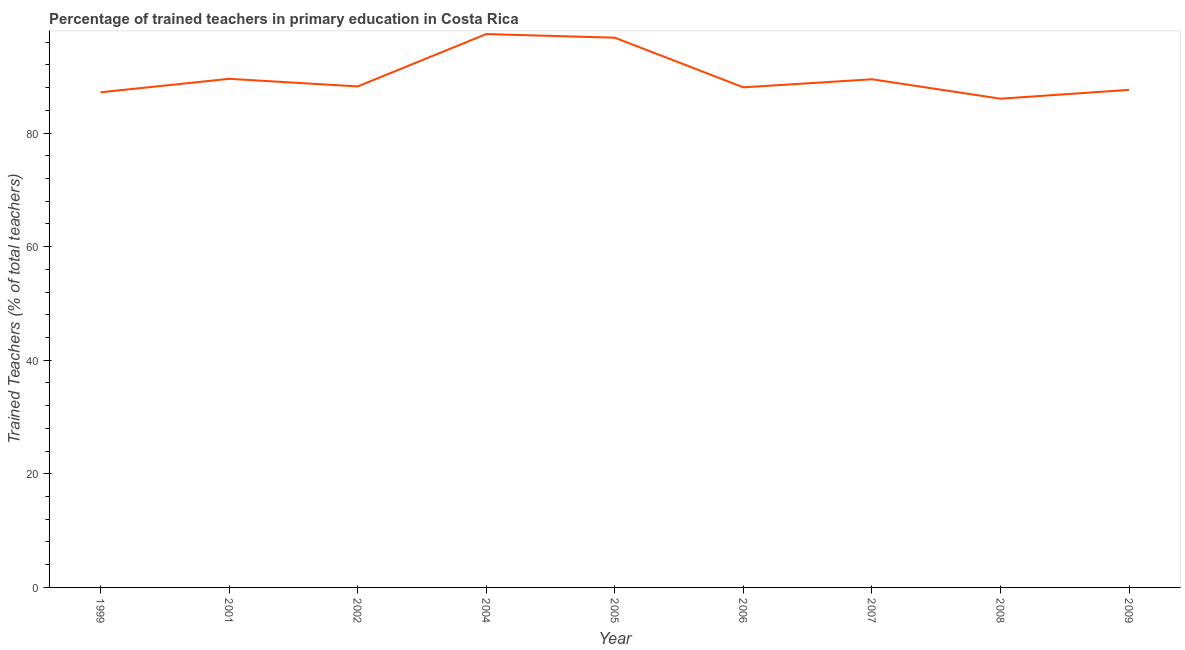What is the percentage of trained teachers in 2007?
Provide a succinct answer. 89.47. Across all years, what is the maximum percentage of trained teachers?
Your answer should be compact. 97.43. Across all years, what is the minimum percentage of trained teachers?
Keep it short and to the point. 86.05. In which year was the percentage of trained teachers maximum?
Your response must be concise. 2004. What is the sum of the percentage of trained teachers?
Your response must be concise. 810.29. What is the difference between the percentage of trained teachers in 2008 and 2009?
Your answer should be compact. -1.55. What is the average percentage of trained teachers per year?
Keep it short and to the point. 90.03. What is the median percentage of trained teachers?
Your answer should be very brief. 88.21. In how many years, is the percentage of trained teachers greater than 88 %?
Your response must be concise. 6. What is the ratio of the percentage of trained teachers in 1999 to that in 2006?
Your answer should be very brief. 0.99. Is the percentage of trained teachers in 2004 less than that in 2006?
Provide a succinct answer. No. Is the difference between the percentage of trained teachers in 2001 and 2006 greater than the difference between any two years?
Provide a succinct answer. No. What is the difference between the highest and the second highest percentage of trained teachers?
Give a very brief answer. 0.64. What is the difference between the highest and the lowest percentage of trained teachers?
Make the answer very short. 11.38. In how many years, is the percentage of trained teachers greater than the average percentage of trained teachers taken over all years?
Provide a succinct answer. 2. How many lines are there?
Give a very brief answer. 1. Does the graph contain grids?
Your answer should be compact. No. What is the title of the graph?
Your answer should be compact. Percentage of trained teachers in primary education in Costa Rica. What is the label or title of the Y-axis?
Provide a short and direct response. Trained Teachers (% of total teachers). What is the Trained Teachers (% of total teachers) of 1999?
Keep it short and to the point. 87.18. What is the Trained Teachers (% of total teachers) in 2001?
Your response must be concise. 89.54. What is the Trained Teachers (% of total teachers) in 2002?
Offer a terse response. 88.21. What is the Trained Teachers (% of total teachers) in 2004?
Make the answer very short. 97.43. What is the Trained Teachers (% of total teachers) in 2005?
Your response must be concise. 96.79. What is the Trained Teachers (% of total teachers) of 2006?
Offer a very short reply. 88.04. What is the Trained Teachers (% of total teachers) in 2007?
Make the answer very short. 89.47. What is the Trained Teachers (% of total teachers) in 2008?
Offer a terse response. 86.05. What is the Trained Teachers (% of total teachers) of 2009?
Provide a short and direct response. 87.6. What is the difference between the Trained Teachers (% of total teachers) in 1999 and 2001?
Offer a very short reply. -2.37. What is the difference between the Trained Teachers (% of total teachers) in 1999 and 2002?
Ensure brevity in your answer.  -1.03. What is the difference between the Trained Teachers (% of total teachers) in 1999 and 2004?
Offer a terse response. -10.25. What is the difference between the Trained Teachers (% of total teachers) in 1999 and 2005?
Your answer should be very brief. -9.61. What is the difference between the Trained Teachers (% of total teachers) in 1999 and 2006?
Your answer should be compact. -0.87. What is the difference between the Trained Teachers (% of total teachers) in 1999 and 2007?
Offer a terse response. -2.29. What is the difference between the Trained Teachers (% of total teachers) in 1999 and 2008?
Offer a very short reply. 1.13. What is the difference between the Trained Teachers (% of total teachers) in 1999 and 2009?
Your response must be concise. -0.42. What is the difference between the Trained Teachers (% of total teachers) in 2001 and 2002?
Your response must be concise. 1.34. What is the difference between the Trained Teachers (% of total teachers) in 2001 and 2004?
Offer a very short reply. -7.88. What is the difference between the Trained Teachers (% of total teachers) in 2001 and 2005?
Provide a succinct answer. -7.24. What is the difference between the Trained Teachers (% of total teachers) in 2001 and 2006?
Provide a succinct answer. 1.5. What is the difference between the Trained Teachers (% of total teachers) in 2001 and 2007?
Offer a very short reply. 0.08. What is the difference between the Trained Teachers (% of total teachers) in 2001 and 2008?
Make the answer very short. 3.5. What is the difference between the Trained Teachers (% of total teachers) in 2001 and 2009?
Your answer should be very brief. 1.94. What is the difference between the Trained Teachers (% of total teachers) in 2002 and 2004?
Offer a terse response. -9.22. What is the difference between the Trained Teachers (% of total teachers) in 2002 and 2005?
Keep it short and to the point. -8.58. What is the difference between the Trained Teachers (% of total teachers) in 2002 and 2006?
Provide a succinct answer. 0.16. What is the difference between the Trained Teachers (% of total teachers) in 2002 and 2007?
Offer a terse response. -1.26. What is the difference between the Trained Teachers (% of total teachers) in 2002 and 2008?
Provide a short and direct response. 2.16. What is the difference between the Trained Teachers (% of total teachers) in 2002 and 2009?
Your answer should be compact. 0.61. What is the difference between the Trained Teachers (% of total teachers) in 2004 and 2005?
Offer a terse response. 0.64. What is the difference between the Trained Teachers (% of total teachers) in 2004 and 2006?
Give a very brief answer. 9.38. What is the difference between the Trained Teachers (% of total teachers) in 2004 and 2007?
Make the answer very short. 7.96. What is the difference between the Trained Teachers (% of total teachers) in 2004 and 2008?
Give a very brief answer. 11.38. What is the difference between the Trained Teachers (% of total teachers) in 2004 and 2009?
Your answer should be very brief. 9.83. What is the difference between the Trained Teachers (% of total teachers) in 2005 and 2006?
Keep it short and to the point. 8.74. What is the difference between the Trained Teachers (% of total teachers) in 2005 and 2007?
Make the answer very short. 7.32. What is the difference between the Trained Teachers (% of total teachers) in 2005 and 2008?
Give a very brief answer. 10.74. What is the difference between the Trained Teachers (% of total teachers) in 2005 and 2009?
Provide a short and direct response. 9.19. What is the difference between the Trained Teachers (% of total teachers) in 2006 and 2007?
Keep it short and to the point. -1.42. What is the difference between the Trained Teachers (% of total teachers) in 2006 and 2008?
Your answer should be very brief. 2. What is the difference between the Trained Teachers (% of total teachers) in 2006 and 2009?
Keep it short and to the point. 0.44. What is the difference between the Trained Teachers (% of total teachers) in 2007 and 2008?
Give a very brief answer. 3.42. What is the difference between the Trained Teachers (% of total teachers) in 2007 and 2009?
Give a very brief answer. 1.86. What is the difference between the Trained Teachers (% of total teachers) in 2008 and 2009?
Offer a very short reply. -1.55. What is the ratio of the Trained Teachers (% of total teachers) in 1999 to that in 2001?
Your answer should be compact. 0.97. What is the ratio of the Trained Teachers (% of total teachers) in 1999 to that in 2002?
Offer a very short reply. 0.99. What is the ratio of the Trained Teachers (% of total teachers) in 1999 to that in 2004?
Offer a terse response. 0.9. What is the ratio of the Trained Teachers (% of total teachers) in 1999 to that in 2005?
Keep it short and to the point. 0.9. What is the ratio of the Trained Teachers (% of total teachers) in 1999 to that in 2008?
Provide a short and direct response. 1.01. What is the ratio of the Trained Teachers (% of total teachers) in 1999 to that in 2009?
Keep it short and to the point. 0.99. What is the ratio of the Trained Teachers (% of total teachers) in 2001 to that in 2004?
Provide a short and direct response. 0.92. What is the ratio of the Trained Teachers (% of total teachers) in 2001 to that in 2005?
Ensure brevity in your answer.  0.93. What is the ratio of the Trained Teachers (% of total teachers) in 2001 to that in 2007?
Ensure brevity in your answer.  1. What is the ratio of the Trained Teachers (% of total teachers) in 2001 to that in 2008?
Make the answer very short. 1.04. What is the ratio of the Trained Teachers (% of total teachers) in 2001 to that in 2009?
Provide a short and direct response. 1.02. What is the ratio of the Trained Teachers (% of total teachers) in 2002 to that in 2004?
Keep it short and to the point. 0.91. What is the ratio of the Trained Teachers (% of total teachers) in 2002 to that in 2005?
Your answer should be very brief. 0.91. What is the ratio of the Trained Teachers (% of total teachers) in 2002 to that in 2006?
Offer a very short reply. 1. What is the ratio of the Trained Teachers (% of total teachers) in 2002 to that in 2007?
Your answer should be very brief. 0.99. What is the ratio of the Trained Teachers (% of total teachers) in 2002 to that in 2008?
Ensure brevity in your answer.  1.02. What is the ratio of the Trained Teachers (% of total teachers) in 2002 to that in 2009?
Provide a short and direct response. 1.01. What is the ratio of the Trained Teachers (% of total teachers) in 2004 to that in 2006?
Your answer should be compact. 1.11. What is the ratio of the Trained Teachers (% of total teachers) in 2004 to that in 2007?
Give a very brief answer. 1.09. What is the ratio of the Trained Teachers (% of total teachers) in 2004 to that in 2008?
Provide a succinct answer. 1.13. What is the ratio of the Trained Teachers (% of total teachers) in 2004 to that in 2009?
Offer a terse response. 1.11. What is the ratio of the Trained Teachers (% of total teachers) in 2005 to that in 2006?
Provide a succinct answer. 1.1. What is the ratio of the Trained Teachers (% of total teachers) in 2005 to that in 2007?
Your answer should be very brief. 1.08. What is the ratio of the Trained Teachers (% of total teachers) in 2005 to that in 2008?
Your answer should be compact. 1.12. What is the ratio of the Trained Teachers (% of total teachers) in 2005 to that in 2009?
Your answer should be compact. 1.1. What is the ratio of the Trained Teachers (% of total teachers) in 2006 to that in 2009?
Your answer should be compact. 1. What is the ratio of the Trained Teachers (% of total teachers) in 2007 to that in 2008?
Make the answer very short. 1.04. What is the ratio of the Trained Teachers (% of total teachers) in 2008 to that in 2009?
Keep it short and to the point. 0.98. 